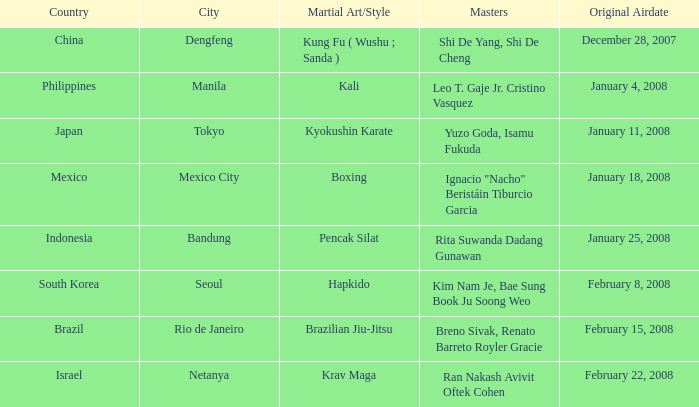How many times did episode 1.8 air? 1.0. 